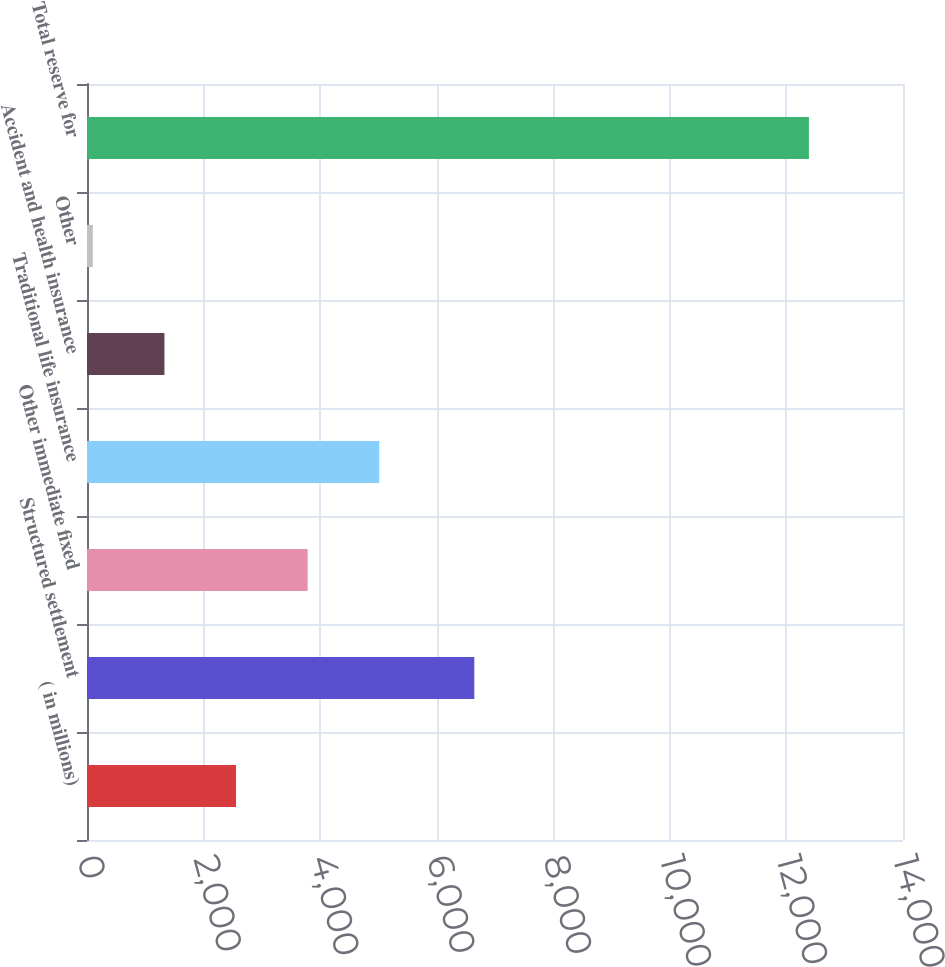<chart> <loc_0><loc_0><loc_500><loc_500><bar_chart><fcel>( in millions)<fcel>Structured settlement<fcel>Other immediate fixed<fcel>Traditional life insurance<fcel>Accident and health insurance<fcel>Other<fcel>Total reserve for<nl><fcel>2557.2<fcel>6645<fcel>3785.8<fcel>5014.4<fcel>1328.6<fcel>100<fcel>12386<nl></chart> 